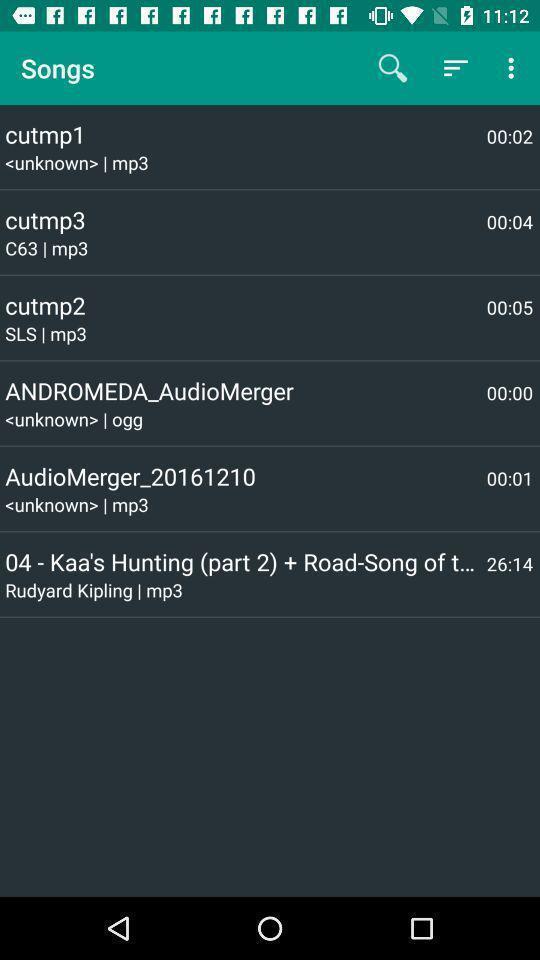Explain the elements present in this screenshot. Screen shows an editting app for songs. 